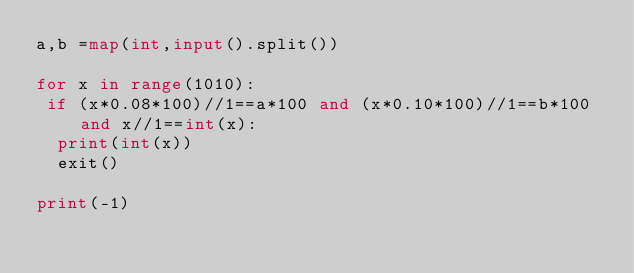<code> <loc_0><loc_0><loc_500><loc_500><_Python_>a,b =map(int,input().split())
 
for x in range(1010):
 if (x*0.08*100)//1==a*100 and (x*0.10*100)//1==b*100 and x//1==int(x):
  print(int(x))
  exit()
  
print(-1)</code> 